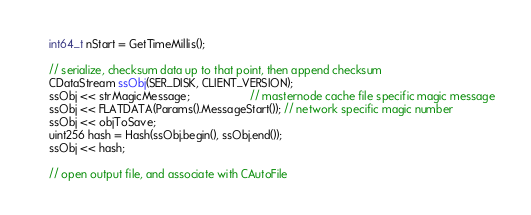<code> <loc_0><loc_0><loc_500><loc_500><_C++_>    int64_t nStart = GetTimeMillis();

    // serialize, checksum data up to that point, then append checksum
    CDataStream ssObj(SER_DISK, CLIENT_VERSION);
    ssObj << strMagicMessage;                   // masternode cache file specific magic message
    ssObj << FLATDATA(Params().MessageStart()); // network specific magic number
    ssObj << objToSave;
    uint256 hash = Hash(ssObj.begin(), ssObj.end());
    ssObj << hash;

    // open output file, and associate with CAutoFile</code> 